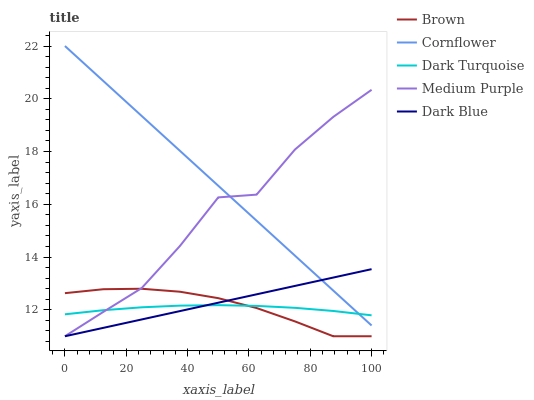Does Dark Turquoise have the minimum area under the curve?
Answer yes or no. Yes. Does Cornflower have the maximum area under the curve?
Answer yes or no. Yes. Does Brown have the minimum area under the curve?
Answer yes or no. No. Does Brown have the maximum area under the curve?
Answer yes or no. No. Is Dark Blue the smoothest?
Answer yes or no. Yes. Is Medium Purple the roughest?
Answer yes or no. Yes. Is Brown the smoothest?
Answer yes or no. No. Is Brown the roughest?
Answer yes or no. No. Does Medium Purple have the lowest value?
Answer yes or no. Yes. Does Dark Turquoise have the lowest value?
Answer yes or no. No. Does Cornflower have the highest value?
Answer yes or no. Yes. Does Brown have the highest value?
Answer yes or no. No. Is Brown less than Cornflower?
Answer yes or no. Yes. Is Cornflower greater than Brown?
Answer yes or no. Yes. Does Dark Blue intersect Brown?
Answer yes or no. Yes. Is Dark Blue less than Brown?
Answer yes or no. No. Is Dark Blue greater than Brown?
Answer yes or no. No. Does Brown intersect Cornflower?
Answer yes or no. No. 